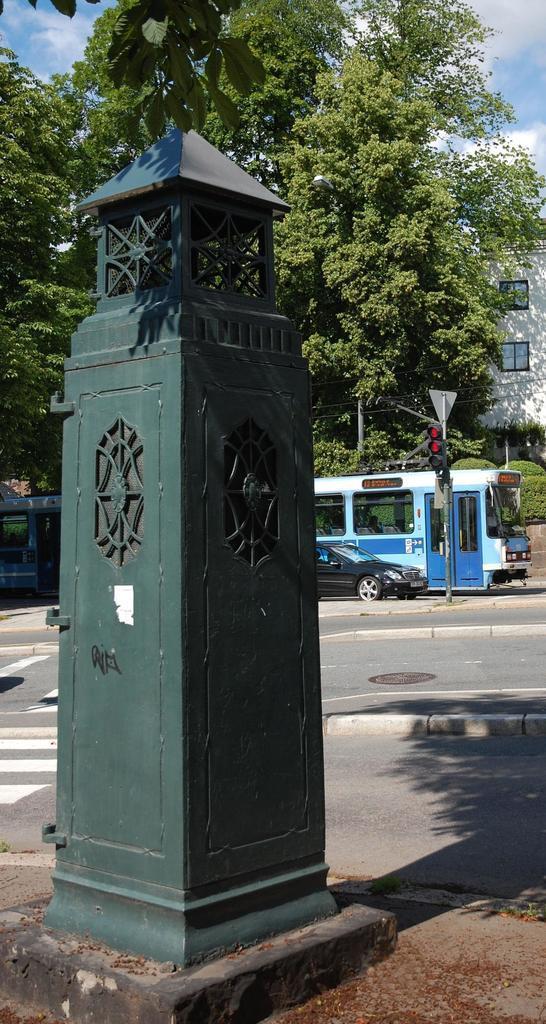Can you describe this image briefly? In this image there is a metal structure, behind this there are few vehicles moving on the road and there is a signal pole. In the background there are trees and buildings. 